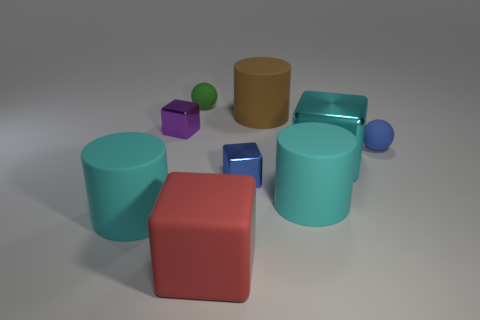Subtract all purple cylinders. Subtract all blue balls. How many cylinders are left? 3 Add 1 red metal things. How many objects exist? 10 Subtract all blocks. How many objects are left? 5 Subtract all brown cylinders. Subtract all purple things. How many objects are left? 7 Add 4 large objects. How many large objects are left? 9 Add 7 purple rubber things. How many purple rubber things exist? 7 Subtract 1 brown cylinders. How many objects are left? 8 